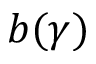<formula> <loc_0><loc_0><loc_500><loc_500>b ( \gamma )</formula> 